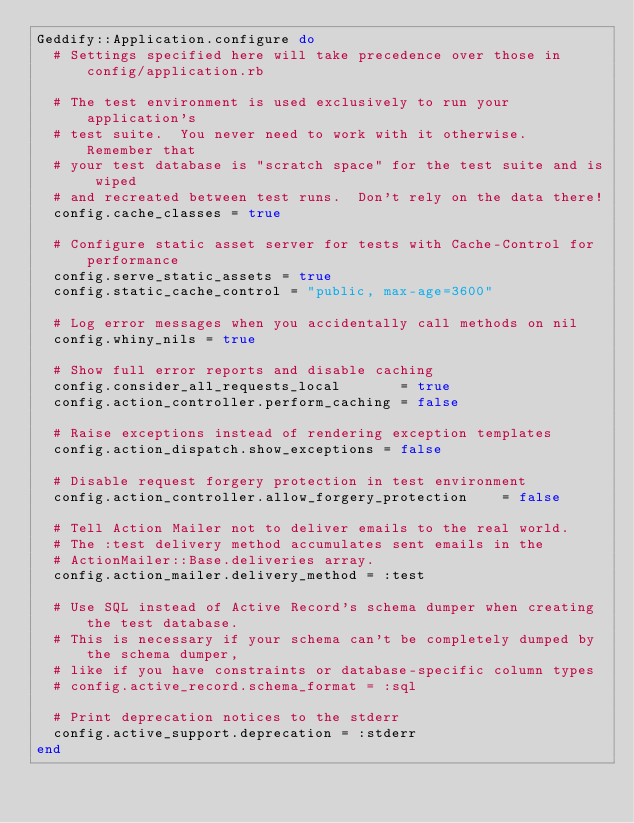Convert code to text. <code><loc_0><loc_0><loc_500><loc_500><_Ruby_>Geddify::Application.configure do
  # Settings specified here will take precedence over those in config/application.rb

  # The test environment is used exclusively to run your application's
  # test suite.  You never need to work with it otherwise.  Remember that
  # your test database is "scratch space" for the test suite and is wiped
  # and recreated between test runs.  Don't rely on the data there!
  config.cache_classes = true

  # Configure static asset server for tests with Cache-Control for performance
  config.serve_static_assets = true
  config.static_cache_control = "public, max-age=3600"

  # Log error messages when you accidentally call methods on nil
  config.whiny_nils = true

  # Show full error reports and disable caching
  config.consider_all_requests_local       = true
  config.action_controller.perform_caching = false

  # Raise exceptions instead of rendering exception templates
  config.action_dispatch.show_exceptions = false

  # Disable request forgery protection in test environment
  config.action_controller.allow_forgery_protection    = false

  # Tell Action Mailer not to deliver emails to the real world.
  # The :test delivery method accumulates sent emails in the
  # ActionMailer::Base.deliveries array.
  config.action_mailer.delivery_method = :test

  # Use SQL instead of Active Record's schema dumper when creating the test database.
  # This is necessary if your schema can't be completely dumped by the schema dumper,
  # like if you have constraints or database-specific column types
  # config.active_record.schema_format = :sql

  # Print deprecation notices to the stderr
  config.active_support.deprecation = :stderr
end
</code> 